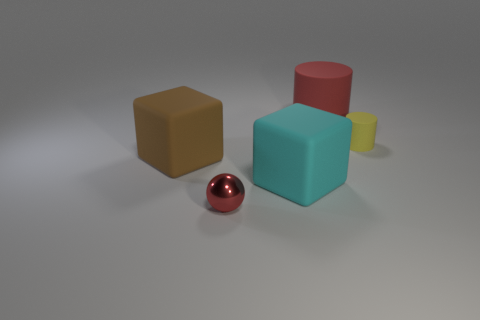Is there any other thing that has the same material as the small red ball?
Keep it short and to the point. No. The other thing that is the same shape as the big brown matte object is what size?
Provide a succinct answer. Large. Is the number of rubber blocks in front of the large cyan object less than the number of brown cubes?
Keep it short and to the point. Yes. There is a yellow matte thing that is right of the brown matte cube; how big is it?
Offer a very short reply. Small. There is another large rubber object that is the same shape as the big cyan matte object; what color is it?
Your answer should be compact. Brown. What number of large cylinders have the same color as the tiny shiny thing?
Your answer should be compact. 1. Is there anything else that is the same shape as the tiny metallic object?
Offer a terse response. No. There is a matte thing that is to the right of the large rubber object behind the large brown cube; are there any large matte objects that are behind it?
Your response must be concise. Yes. How many tiny yellow balls have the same material as the cyan thing?
Your answer should be very brief. 0. There is a red thing that is in front of the small yellow thing; does it have the same size as the matte cube that is on the left side of the cyan rubber block?
Offer a terse response. No. 